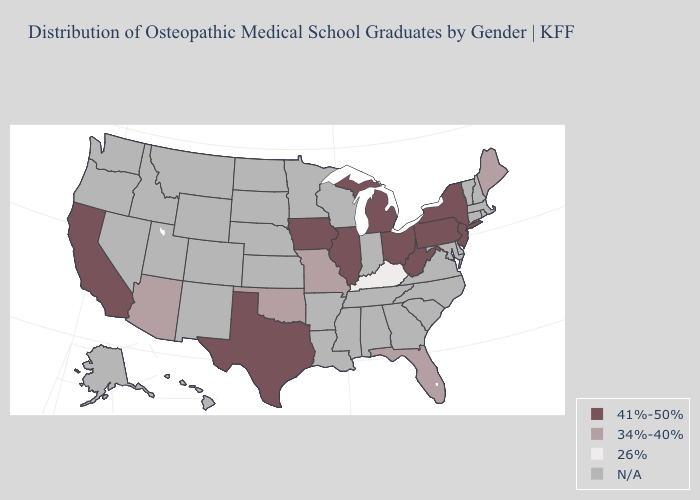Name the states that have a value in the range 34%-40%?
Be succinct. Arizona, Florida, Maine, Missouri, Oklahoma. What is the value of Nebraska?
Concise answer only. N/A. Does Kentucky have the lowest value in the USA?
Keep it brief. Yes. What is the highest value in the USA?
Keep it brief. 41%-50%. What is the lowest value in the USA?
Short answer required. 26%. How many symbols are there in the legend?
Keep it brief. 4. Name the states that have a value in the range 41%-50%?
Give a very brief answer. California, Illinois, Iowa, Michigan, New Jersey, New York, Ohio, Pennsylvania, Texas, West Virginia. What is the value of Mississippi?
Give a very brief answer. N/A. What is the highest value in the West ?
Short answer required. 41%-50%. What is the value of Wyoming?
Short answer required. N/A. Does Arizona have the highest value in the West?
Be succinct. No. What is the value of Alaska?
Be succinct. N/A. 